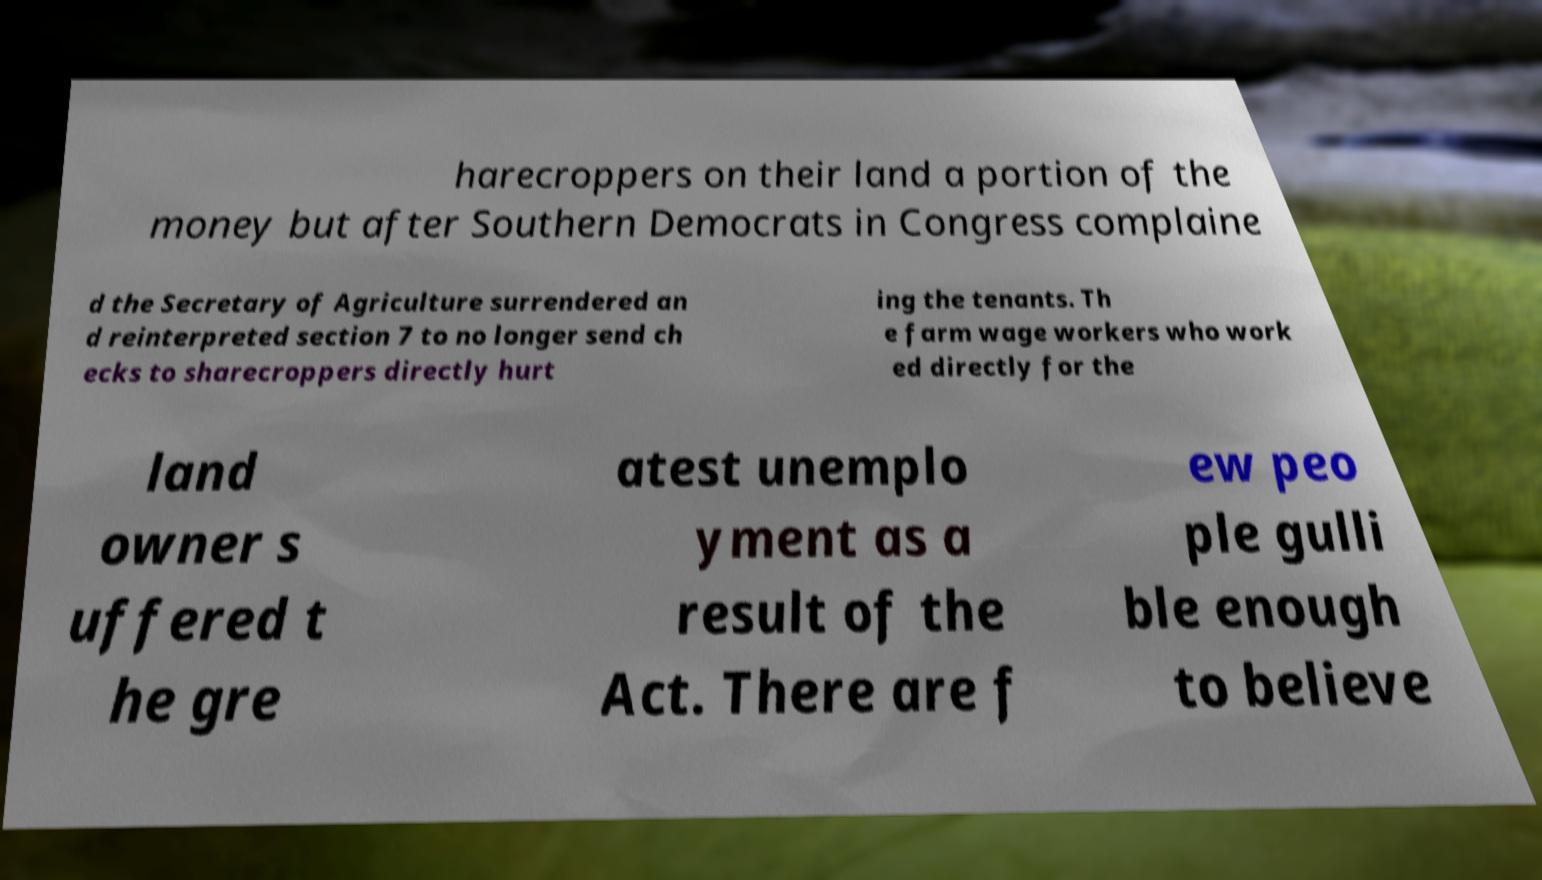Could you extract and type out the text from this image? harecroppers on their land a portion of the money but after Southern Democrats in Congress complaine d the Secretary of Agriculture surrendered an d reinterpreted section 7 to no longer send ch ecks to sharecroppers directly hurt ing the tenants. Th e farm wage workers who work ed directly for the land owner s uffered t he gre atest unemplo yment as a result of the Act. There are f ew peo ple gulli ble enough to believe 